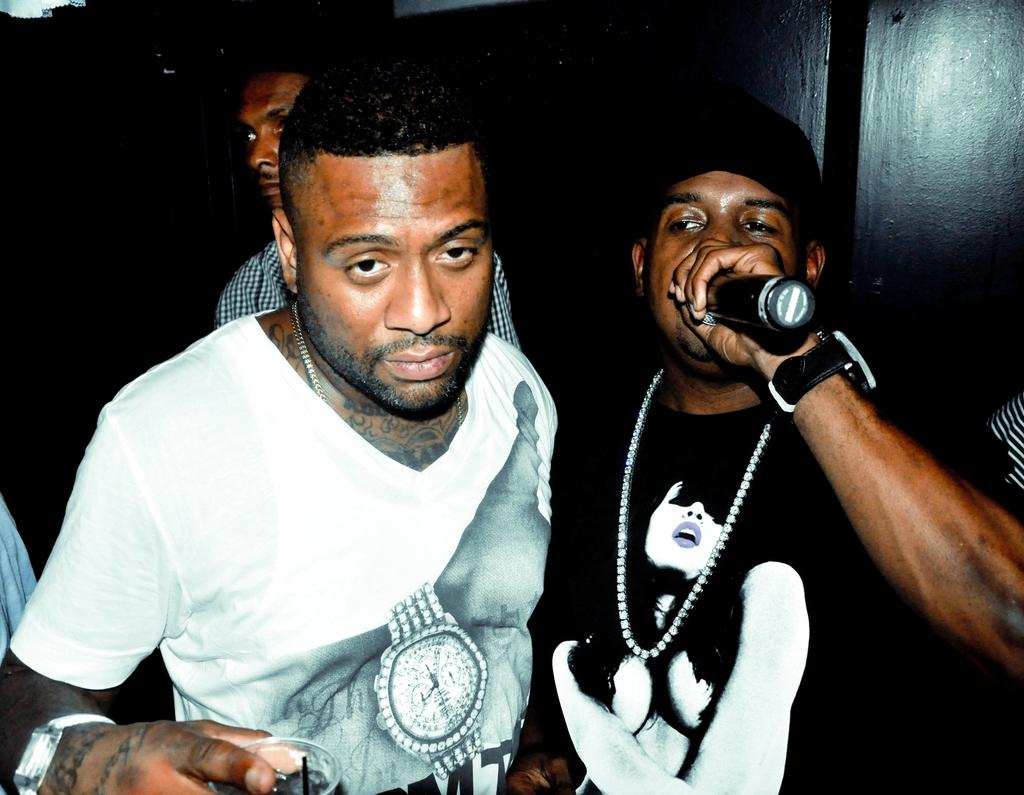How many people are in the image? There are three persons in the image. Where is the first man located in the image? The first man is on the left side of the image. What is the first man holding in the image? The first man is holding a glass. Where is the second man located in the image? The second man is on the right side of the image. What is the second man holding in the image? The second man is holding a microphone. What type of clothing are the men wearing in the image? Both men are wearing t-shirts. How many lizards are crawling on the plate in the image? There are no lizards or plates present in the image. 